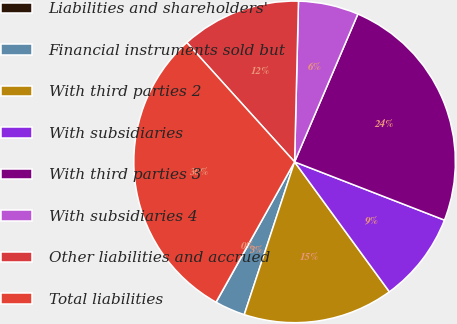<chart> <loc_0><loc_0><loc_500><loc_500><pie_chart><fcel>Liabilities and shareholders'<fcel>Financial instruments sold but<fcel>With third parties 2<fcel>With subsidiaries<fcel>With third parties 3<fcel>With subsidiaries 4<fcel>Other liabilities and accrued<fcel>Total liabilities<nl><fcel>0.02%<fcel>3.04%<fcel>15.1%<fcel>9.07%<fcel>24.46%<fcel>6.05%<fcel>12.08%<fcel>30.18%<nl></chart> 